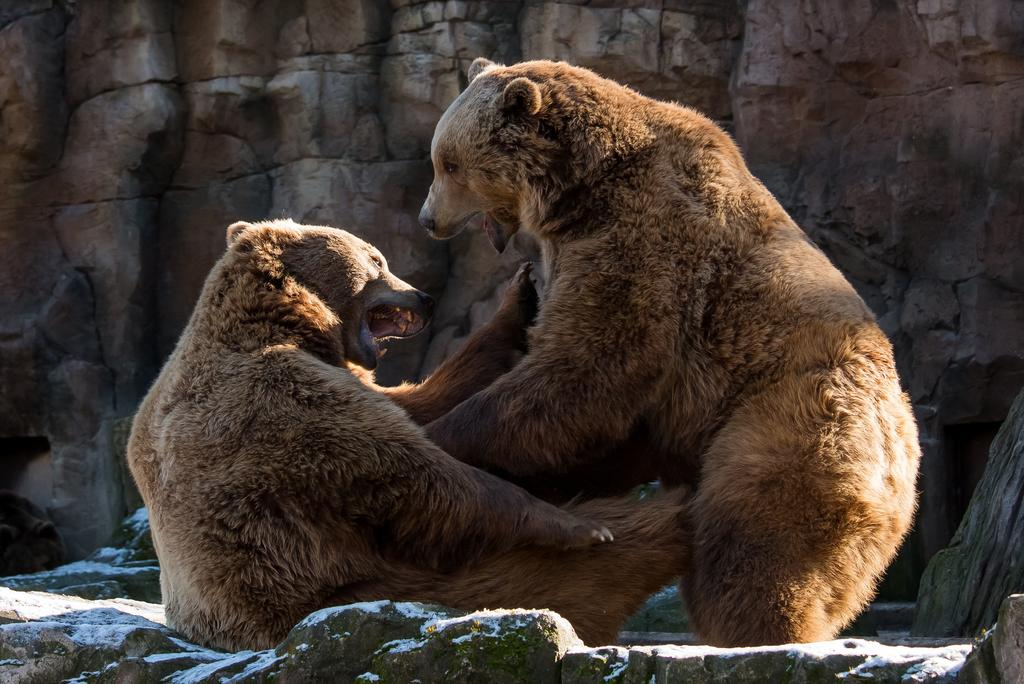How many bears are present in the image? There are two bears in the image. What surface are the bears on? The bears are on a surface, but the specific type of surface is not mentioned in the facts. What type of natural elements can be seen in the image? There are stones and a rock in the image. What type of line can be seen connecting the two bears in the image? There is no line connecting the two bears in the image. 